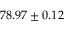<formula> <loc_0><loc_0><loc_500><loc_500>7 8 . 9 7 \pm 0 . 1 2</formula> 